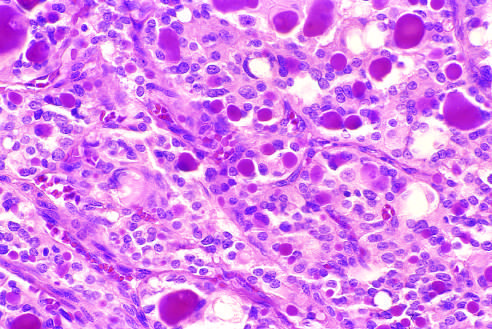what contain recognizable colloid?
Answer the question using a single word or phrase. A few of the glandular lumina 